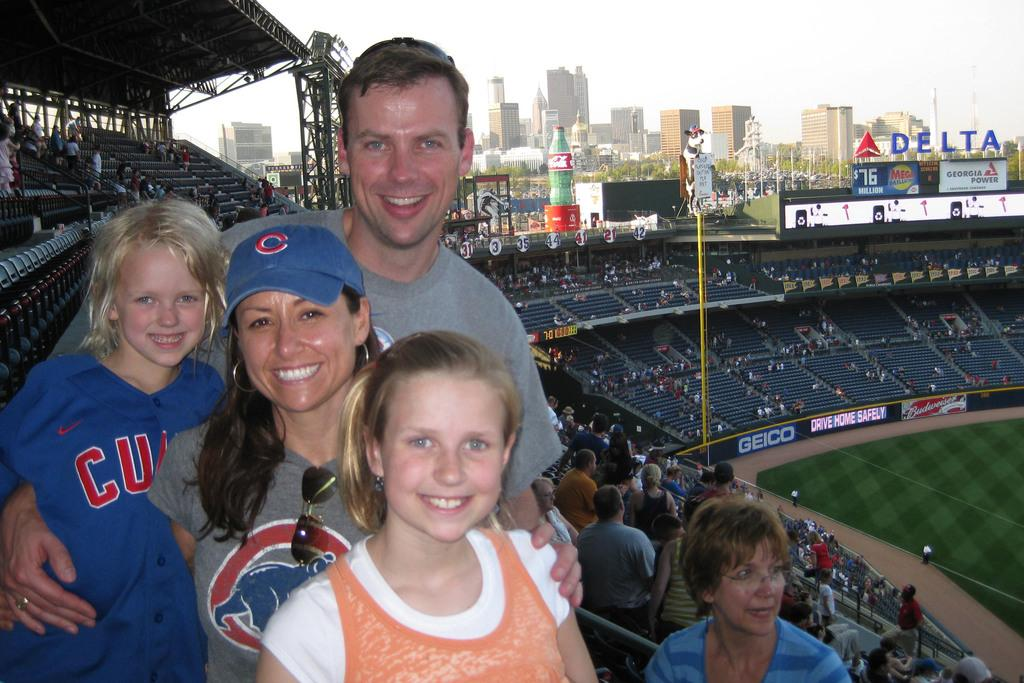<image>
Describe the image concisely. a kid with a Cubs jersey at a game with family 